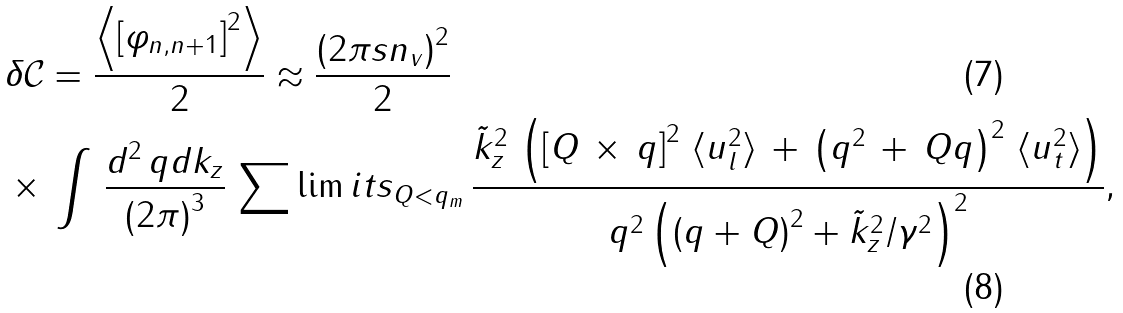<formula> <loc_0><loc_0><loc_500><loc_500>& \, \delta \mathcal { C } = \frac { \left \langle \left [ \varphi _ { n , n + 1 } \right ] ^ { 2 } \right \rangle } { 2 } \approx \frac { \left ( 2 \pi s n _ { v } \right ) ^ { 2 } } { 2 } \\ & \, \times \, \int \, \frac { d ^ { 2 } \, q d k _ { z } } { \left ( 2 \pi \right ) ^ { 3 } } \, \sum \lim i t s _ { Q < q _ { m } } \, \frac { \tilde { k } _ { z } ^ { 2 } \, \left ( \left [ Q \, \times \, q \right ] ^ { 2 } \, \langle u _ { l } ^ { 2 } \rangle \, + \, \left ( q ^ { 2 } \, + \, Q q \right ) ^ { 2 } \, \langle u _ { t } ^ { 2 } \rangle \right ) } { q ^ { 2 } \left ( \left ( q + Q \right ) ^ { 2 } + \tilde { k } _ { z } ^ { 2 } / \gamma ^ { 2 } \right ) ^ { 2 } } ,</formula> 